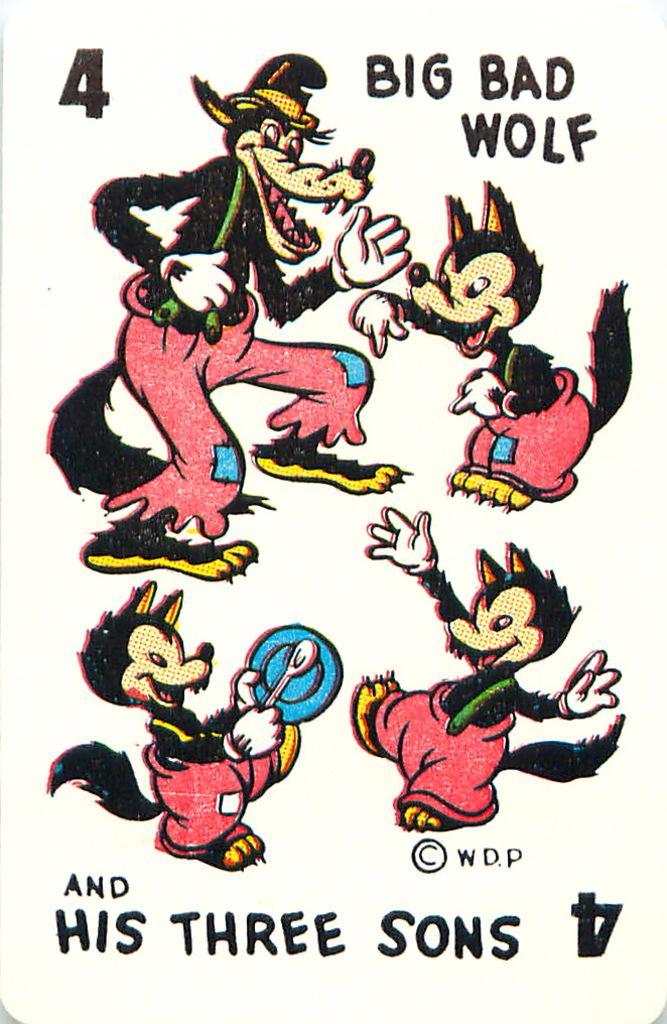Can you describe this image briefly? In this image there are four wolf cartoon images, and on that image it is written as big bad wolf and his three sons. 